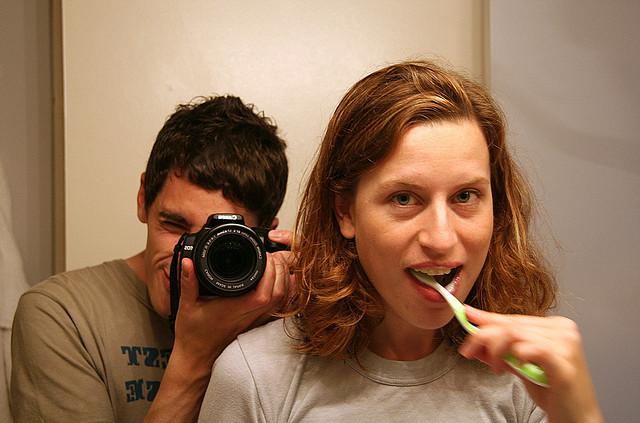What are these people holding?
Be succinct. Toothbrush, camera. What is the man taking a picture of?
Short answer required. Woman. Is he a photographer?
Write a very short answer. Yes. What is the women doing?
Keep it brief. Brushing her teeth. 